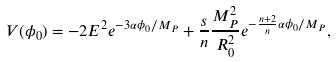<formula> <loc_0><loc_0><loc_500><loc_500>V ( \phi _ { 0 } ) = - 2 E ^ { 2 } e ^ { - 3 \alpha \phi _ { 0 } / M _ { P } } + \frac { s } { n } \frac { M _ { P } ^ { 2 } } { R _ { 0 } ^ { 2 } } e ^ { - \frac { n + 2 } { n } \alpha \phi _ { 0 } / M _ { P } } ,</formula> 